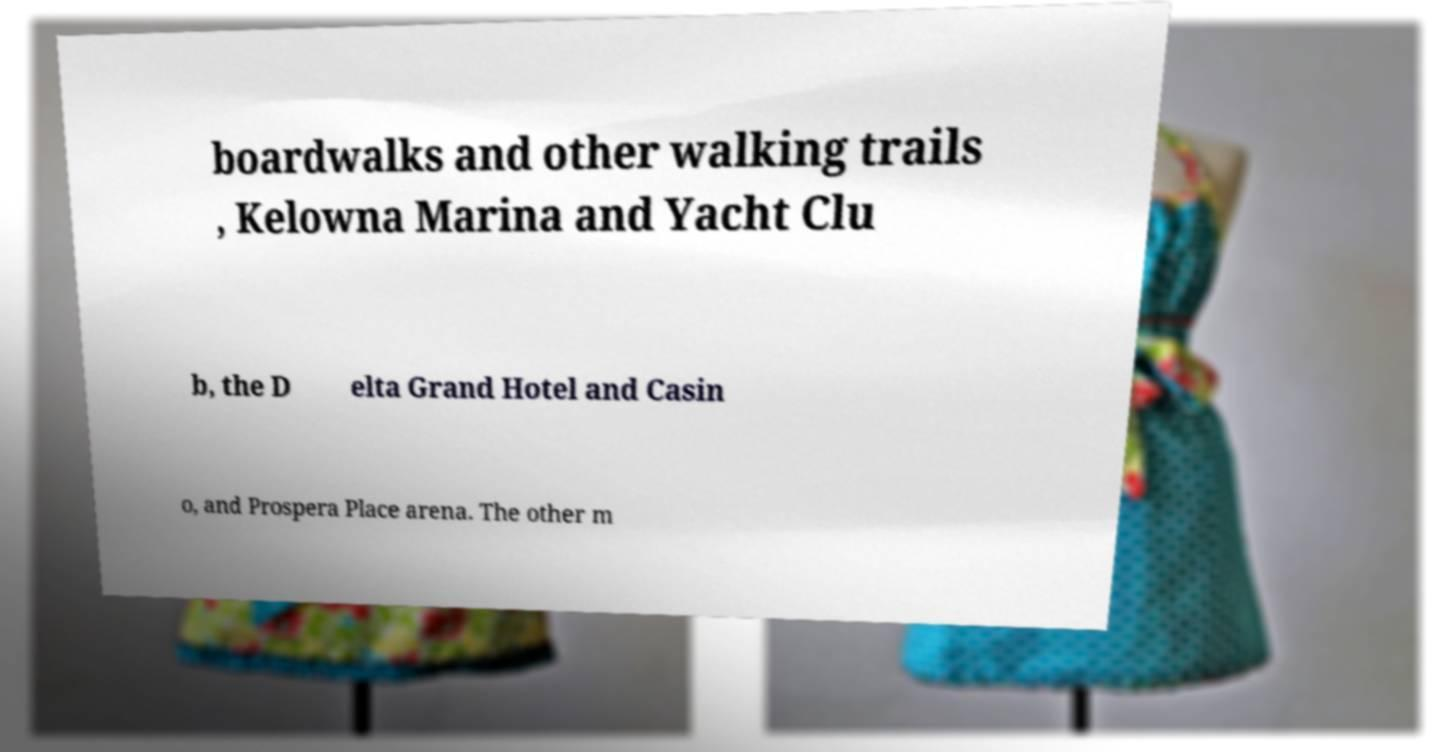Please read and relay the text visible in this image. What does it say? boardwalks and other walking trails , Kelowna Marina and Yacht Clu b, the D elta Grand Hotel and Casin o, and Prospera Place arena. The other m 